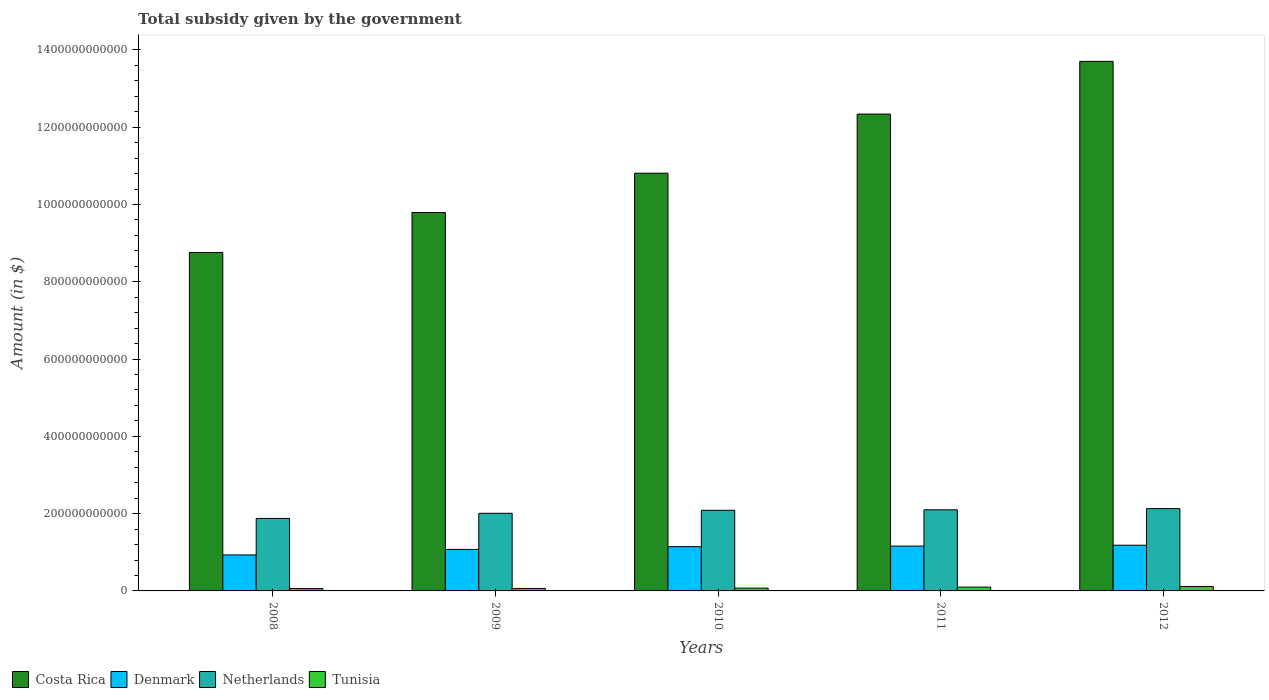How many different coloured bars are there?
Offer a very short reply. 4. Are the number of bars per tick equal to the number of legend labels?
Your answer should be very brief. Yes. How many bars are there on the 1st tick from the right?
Your answer should be compact. 4. In how many cases, is the number of bars for a given year not equal to the number of legend labels?
Offer a terse response. 0. What is the total revenue collected by the government in Tunisia in 2010?
Keep it short and to the point. 7.24e+09. Across all years, what is the maximum total revenue collected by the government in Netherlands?
Offer a very short reply. 2.13e+11. Across all years, what is the minimum total revenue collected by the government in Costa Rica?
Give a very brief answer. 8.76e+11. In which year was the total revenue collected by the government in Netherlands maximum?
Offer a terse response. 2012. What is the total total revenue collected by the government in Tunisia in the graph?
Offer a very short reply. 4.12e+1. What is the difference between the total revenue collected by the government in Denmark in 2009 and that in 2011?
Keep it short and to the point. -8.61e+09. What is the difference between the total revenue collected by the government in Tunisia in 2008 and the total revenue collected by the government in Costa Rica in 2011?
Your answer should be very brief. -1.23e+12. What is the average total revenue collected by the government in Tunisia per year?
Your answer should be very brief. 8.24e+09. In the year 2012, what is the difference between the total revenue collected by the government in Tunisia and total revenue collected by the government in Costa Rica?
Your answer should be compact. -1.36e+12. What is the ratio of the total revenue collected by the government in Costa Rica in 2008 to that in 2012?
Your answer should be very brief. 0.64. What is the difference between the highest and the second highest total revenue collected by the government in Costa Rica?
Your answer should be very brief. 1.36e+11. What is the difference between the highest and the lowest total revenue collected by the government in Costa Rica?
Provide a short and direct response. 4.95e+11. In how many years, is the total revenue collected by the government in Tunisia greater than the average total revenue collected by the government in Tunisia taken over all years?
Provide a short and direct response. 2. What does the 1st bar from the right in 2011 represents?
Ensure brevity in your answer.  Tunisia. Is it the case that in every year, the sum of the total revenue collected by the government in Denmark and total revenue collected by the government in Netherlands is greater than the total revenue collected by the government in Tunisia?
Give a very brief answer. Yes. How many bars are there?
Your response must be concise. 20. What is the difference between two consecutive major ticks on the Y-axis?
Give a very brief answer. 2.00e+11. Are the values on the major ticks of Y-axis written in scientific E-notation?
Ensure brevity in your answer.  No. Does the graph contain any zero values?
Offer a very short reply. No. Does the graph contain grids?
Your response must be concise. No. Where does the legend appear in the graph?
Keep it short and to the point. Bottom left. What is the title of the graph?
Provide a succinct answer. Total subsidy given by the government. What is the label or title of the X-axis?
Keep it short and to the point. Years. What is the label or title of the Y-axis?
Your response must be concise. Amount (in $). What is the Amount (in $) in Costa Rica in 2008?
Give a very brief answer. 8.76e+11. What is the Amount (in $) in Denmark in 2008?
Your answer should be compact. 9.31e+1. What is the Amount (in $) in Netherlands in 2008?
Your answer should be very brief. 1.88e+11. What is the Amount (in $) in Tunisia in 2008?
Keep it short and to the point. 6.13e+09. What is the Amount (in $) of Costa Rica in 2009?
Your answer should be compact. 9.79e+11. What is the Amount (in $) in Denmark in 2009?
Offer a terse response. 1.07e+11. What is the Amount (in $) of Netherlands in 2009?
Offer a terse response. 2.01e+11. What is the Amount (in $) of Tunisia in 2009?
Offer a very short reply. 6.41e+09. What is the Amount (in $) of Costa Rica in 2010?
Provide a succinct answer. 1.08e+12. What is the Amount (in $) in Denmark in 2010?
Ensure brevity in your answer.  1.15e+11. What is the Amount (in $) in Netherlands in 2010?
Keep it short and to the point. 2.09e+11. What is the Amount (in $) in Tunisia in 2010?
Your answer should be compact. 7.24e+09. What is the Amount (in $) in Costa Rica in 2011?
Offer a very short reply. 1.23e+12. What is the Amount (in $) of Denmark in 2011?
Ensure brevity in your answer.  1.16e+11. What is the Amount (in $) in Netherlands in 2011?
Keep it short and to the point. 2.10e+11. What is the Amount (in $) in Tunisia in 2011?
Offer a terse response. 9.89e+09. What is the Amount (in $) in Costa Rica in 2012?
Your answer should be compact. 1.37e+12. What is the Amount (in $) of Denmark in 2012?
Your answer should be compact. 1.18e+11. What is the Amount (in $) in Netherlands in 2012?
Offer a very short reply. 2.13e+11. What is the Amount (in $) of Tunisia in 2012?
Your answer should be compact. 1.15e+1. Across all years, what is the maximum Amount (in $) of Costa Rica?
Ensure brevity in your answer.  1.37e+12. Across all years, what is the maximum Amount (in $) in Denmark?
Keep it short and to the point. 1.18e+11. Across all years, what is the maximum Amount (in $) of Netherlands?
Your answer should be very brief. 2.13e+11. Across all years, what is the maximum Amount (in $) of Tunisia?
Offer a very short reply. 1.15e+1. Across all years, what is the minimum Amount (in $) of Costa Rica?
Offer a very short reply. 8.76e+11. Across all years, what is the minimum Amount (in $) of Denmark?
Your answer should be compact. 9.31e+1. Across all years, what is the minimum Amount (in $) in Netherlands?
Your answer should be very brief. 1.88e+11. Across all years, what is the minimum Amount (in $) of Tunisia?
Give a very brief answer. 6.13e+09. What is the total Amount (in $) of Costa Rica in the graph?
Provide a short and direct response. 5.54e+12. What is the total Amount (in $) of Denmark in the graph?
Your answer should be very brief. 5.49e+11. What is the total Amount (in $) of Netherlands in the graph?
Provide a short and direct response. 1.02e+12. What is the total Amount (in $) of Tunisia in the graph?
Offer a very short reply. 4.12e+1. What is the difference between the Amount (in $) of Costa Rica in 2008 and that in 2009?
Offer a terse response. -1.03e+11. What is the difference between the Amount (in $) of Denmark in 2008 and that in 2009?
Ensure brevity in your answer.  -1.43e+1. What is the difference between the Amount (in $) in Netherlands in 2008 and that in 2009?
Your answer should be compact. -1.33e+1. What is the difference between the Amount (in $) of Tunisia in 2008 and that in 2009?
Provide a short and direct response. -2.86e+08. What is the difference between the Amount (in $) in Costa Rica in 2008 and that in 2010?
Offer a very short reply. -2.05e+11. What is the difference between the Amount (in $) of Denmark in 2008 and that in 2010?
Provide a succinct answer. -2.14e+1. What is the difference between the Amount (in $) of Netherlands in 2008 and that in 2010?
Give a very brief answer. -2.10e+1. What is the difference between the Amount (in $) in Tunisia in 2008 and that in 2010?
Keep it short and to the point. -1.11e+09. What is the difference between the Amount (in $) of Costa Rica in 2008 and that in 2011?
Provide a short and direct response. -3.58e+11. What is the difference between the Amount (in $) in Denmark in 2008 and that in 2011?
Keep it short and to the point. -2.29e+1. What is the difference between the Amount (in $) in Netherlands in 2008 and that in 2011?
Give a very brief answer. -2.23e+1. What is the difference between the Amount (in $) in Tunisia in 2008 and that in 2011?
Offer a terse response. -3.76e+09. What is the difference between the Amount (in $) in Costa Rica in 2008 and that in 2012?
Offer a terse response. -4.95e+11. What is the difference between the Amount (in $) of Denmark in 2008 and that in 2012?
Your response must be concise. -2.52e+1. What is the difference between the Amount (in $) in Netherlands in 2008 and that in 2012?
Offer a very short reply. -2.55e+1. What is the difference between the Amount (in $) in Tunisia in 2008 and that in 2012?
Make the answer very short. -5.40e+09. What is the difference between the Amount (in $) of Costa Rica in 2009 and that in 2010?
Provide a short and direct response. -1.02e+11. What is the difference between the Amount (in $) of Denmark in 2009 and that in 2010?
Your answer should be compact. -7.08e+09. What is the difference between the Amount (in $) in Netherlands in 2009 and that in 2010?
Give a very brief answer. -7.71e+09. What is the difference between the Amount (in $) in Tunisia in 2009 and that in 2010?
Your response must be concise. -8.23e+08. What is the difference between the Amount (in $) in Costa Rica in 2009 and that in 2011?
Provide a short and direct response. -2.55e+11. What is the difference between the Amount (in $) of Denmark in 2009 and that in 2011?
Make the answer very short. -8.61e+09. What is the difference between the Amount (in $) in Netherlands in 2009 and that in 2011?
Ensure brevity in your answer.  -8.99e+09. What is the difference between the Amount (in $) in Tunisia in 2009 and that in 2011?
Provide a short and direct response. -3.48e+09. What is the difference between the Amount (in $) in Costa Rica in 2009 and that in 2012?
Give a very brief answer. -3.91e+11. What is the difference between the Amount (in $) of Denmark in 2009 and that in 2012?
Keep it short and to the point. -1.09e+1. What is the difference between the Amount (in $) in Netherlands in 2009 and that in 2012?
Your answer should be very brief. -1.22e+1. What is the difference between the Amount (in $) of Tunisia in 2009 and that in 2012?
Your answer should be very brief. -5.11e+09. What is the difference between the Amount (in $) of Costa Rica in 2010 and that in 2011?
Offer a very short reply. -1.53e+11. What is the difference between the Amount (in $) in Denmark in 2010 and that in 2011?
Provide a succinct answer. -1.53e+09. What is the difference between the Amount (in $) in Netherlands in 2010 and that in 2011?
Offer a very short reply. -1.28e+09. What is the difference between the Amount (in $) of Tunisia in 2010 and that in 2011?
Provide a succinct answer. -2.66e+09. What is the difference between the Amount (in $) in Costa Rica in 2010 and that in 2012?
Provide a succinct answer. -2.89e+11. What is the difference between the Amount (in $) in Denmark in 2010 and that in 2012?
Provide a short and direct response. -3.80e+09. What is the difference between the Amount (in $) in Netherlands in 2010 and that in 2012?
Make the answer very short. -4.46e+09. What is the difference between the Amount (in $) in Tunisia in 2010 and that in 2012?
Give a very brief answer. -4.29e+09. What is the difference between the Amount (in $) of Costa Rica in 2011 and that in 2012?
Offer a terse response. -1.36e+11. What is the difference between the Amount (in $) in Denmark in 2011 and that in 2012?
Give a very brief answer. -2.27e+09. What is the difference between the Amount (in $) of Netherlands in 2011 and that in 2012?
Make the answer very short. -3.18e+09. What is the difference between the Amount (in $) of Tunisia in 2011 and that in 2012?
Your response must be concise. -1.64e+09. What is the difference between the Amount (in $) in Costa Rica in 2008 and the Amount (in $) in Denmark in 2009?
Give a very brief answer. 7.68e+11. What is the difference between the Amount (in $) in Costa Rica in 2008 and the Amount (in $) in Netherlands in 2009?
Ensure brevity in your answer.  6.75e+11. What is the difference between the Amount (in $) in Costa Rica in 2008 and the Amount (in $) in Tunisia in 2009?
Your answer should be very brief. 8.69e+11. What is the difference between the Amount (in $) in Denmark in 2008 and the Amount (in $) in Netherlands in 2009?
Your response must be concise. -1.08e+11. What is the difference between the Amount (in $) in Denmark in 2008 and the Amount (in $) in Tunisia in 2009?
Offer a very short reply. 8.67e+1. What is the difference between the Amount (in $) in Netherlands in 2008 and the Amount (in $) in Tunisia in 2009?
Your answer should be compact. 1.81e+11. What is the difference between the Amount (in $) of Costa Rica in 2008 and the Amount (in $) of Denmark in 2010?
Your response must be concise. 7.61e+11. What is the difference between the Amount (in $) of Costa Rica in 2008 and the Amount (in $) of Netherlands in 2010?
Your answer should be very brief. 6.67e+11. What is the difference between the Amount (in $) in Costa Rica in 2008 and the Amount (in $) in Tunisia in 2010?
Give a very brief answer. 8.69e+11. What is the difference between the Amount (in $) of Denmark in 2008 and the Amount (in $) of Netherlands in 2010?
Provide a short and direct response. -1.15e+11. What is the difference between the Amount (in $) of Denmark in 2008 and the Amount (in $) of Tunisia in 2010?
Offer a very short reply. 8.59e+1. What is the difference between the Amount (in $) of Netherlands in 2008 and the Amount (in $) of Tunisia in 2010?
Ensure brevity in your answer.  1.80e+11. What is the difference between the Amount (in $) of Costa Rica in 2008 and the Amount (in $) of Denmark in 2011?
Your answer should be compact. 7.60e+11. What is the difference between the Amount (in $) in Costa Rica in 2008 and the Amount (in $) in Netherlands in 2011?
Provide a succinct answer. 6.66e+11. What is the difference between the Amount (in $) of Costa Rica in 2008 and the Amount (in $) of Tunisia in 2011?
Offer a terse response. 8.66e+11. What is the difference between the Amount (in $) of Denmark in 2008 and the Amount (in $) of Netherlands in 2011?
Your answer should be very brief. -1.17e+11. What is the difference between the Amount (in $) in Denmark in 2008 and the Amount (in $) in Tunisia in 2011?
Make the answer very short. 8.32e+1. What is the difference between the Amount (in $) in Netherlands in 2008 and the Amount (in $) in Tunisia in 2011?
Your answer should be compact. 1.78e+11. What is the difference between the Amount (in $) of Costa Rica in 2008 and the Amount (in $) of Denmark in 2012?
Make the answer very short. 7.58e+11. What is the difference between the Amount (in $) of Costa Rica in 2008 and the Amount (in $) of Netherlands in 2012?
Provide a succinct answer. 6.63e+11. What is the difference between the Amount (in $) of Costa Rica in 2008 and the Amount (in $) of Tunisia in 2012?
Your answer should be compact. 8.64e+11. What is the difference between the Amount (in $) in Denmark in 2008 and the Amount (in $) in Netherlands in 2012?
Your answer should be very brief. -1.20e+11. What is the difference between the Amount (in $) of Denmark in 2008 and the Amount (in $) of Tunisia in 2012?
Make the answer very short. 8.16e+1. What is the difference between the Amount (in $) in Netherlands in 2008 and the Amount (in $) in Tunisia in 2012?
Your response must be concise. 1.76e+11. What is the difference between the Amount (in $) of Costa Rica in 2009 and the Amount (in $) of Denmark in 2010?
Offer a terse response. 8.65e+11. What is the difference between the Amount (in $) in Costa Rica in 2009 and the Amount (in $) in Netherlands in 2010?
Offer a terse response. 7.71e+11. What is the difference between the Amount (in $) in Costa Rica in 2009 and the Amount (in $) in Tunisia in 2010?
Offer a terse response. 9.72e+11. What is the difference between the Amount (in $) of Denmark in 2009 and the Amount (in $) of Netherlands in 2010?
Offer a terse response. -1.01e+11. What is the difference between the Amount (in $) in Denmark in 2009 and the Amount (in $) in Tunisia in 2010?
Ensure brevity in your answer.  1.00e+11. What is the difference between the Amount (in $) in Netherlands in 2009 and the Amount (in $) in Tunisia in 2010?
Your answer should be compact. 1.94e+11. What is the difference between the Amount (in $) in Costa Rica in 2009 and the Amount (in $) in Denmark in 2011?
Your answer should be compact. 8.63e+11. What is the difference between the Amount (in $) in Costa Rica in 2009 and the Amount (in $) in Netherlands in 2011?
Offer a terse response. 7.69e+11. What is the difference between the Amount (in $) in Costa Rica in 2009 and the Amount (in $) in Tunisia in 2011?
Make the answer very short. 9.69e+11. What is the difference between the Amount (in $) of Denmark in 2009 and the Amount (in $) of Netherlands in 2011?
Give a very brief answer. -1.02e+11. What is the difference between the Amount (in $) of Denmark in 2009 and the Amount (in $) of Tunisia in 2011?
Offer a very short reply. 9.75e+1. What is the difference between the Amount (in $) of Netherlands in 2009 and the Amount (in $) of Tunisia in 2011?
Offer a terse response. 1.91e+11. What is the difference between the Amount (in $) in Costa Rica in 2009 and the Amount (in $) in Denmark in 2012?
Your answer should be compact. 8.61e+11. What is the difference between the Amount (in $) of Costa Rica in 2009 and the Amount (in $) of Netherlands in 2012?
Offer a terse response. 7.66e+11. What is the difference between the Amount (in $) in Costa Rica in 2009 and the Amount (in $) in Tunisia in 2012?
Make the answer very short. 9.68e+11. What is the difference between the Amount (in $) in Denmark in 2009 and the Amount (in $) in Netherlands in 2012?
Provide a short and direct response. -1.06e+11. What is the difference between the Amount (in $) in Denmark in 2009 and the Amount (in $) in Tunisia in 2012?
Provide a succinct answer. 9.59e+1. What is the difference between the Amount (in $) in Netherlands in 2009 and the Amount (in $) in Tunisia in 2012?
Offer a terse response. 1.89e+11. What is the difference between the Amount (in $) in Costa Rica in 2010 and the Amount (in $) in Denmark in 2011?
Your answer should be compact. 9.65e+11. What is the difference between the Amount (in $) of Costa Rica in 2010 and the Amount (in $) of Netherlands in 2011?
Your response must be concise. 8.71e+11. What is the difference between the Amount (in $) in Costa Rica in 2010 and the Amount (in $) in Tunisia in 2011?
Ensure brevity in your answer.  1.07e+12. What is the difference between the Amount (in $) of Denmark in 2010 and the Amount (in $) of Netherlands in 2011?
Make the answer very short. -9.54e+1. What is the difference between the Amount (in $) in Denmark in 2010 and the Amount (in $) in Tunisia in 2011?
Provide a short and direct response. 1.05e+11. What is the difference between the Amount (in $) of Netherlands in 2010 and the Amount (in $) of Tunisia in 2011?
Provide a short and direct response. 1.99e+11. What is the difference between the Amount (in $) of Costa Rica in 2010 and the Amount (in $) of Denmark in 2012?
Your response must be concise. 9.63e+11. What is the difference between the Amount (in $) in Costa Rica in 2010 and the Amount (in $) in Netherlands in 2012?
Your answer should be compact. 8.68e+11. What is the difference between the Amount (in $) in Costa Rica in 2010 and the Amount (in $) in Tunisia in 2012?
Your answer should be compact. 1.07e+12. What is the difference between the Amount (in $) in Denmark in 2010 and the Amount (in $) in Netherlands in 2012?
Offer a terse response. -9.86e+1. What is the difference between the Amount (in $) in Denmark in 2010 and the Amount (in $) in Tunisia in 2012?
Your answer should be very brief. 1.03e+11. What is the difference between the Amount (in $) in Netherlands in 2010 and the Amount (in $) in Tunisia in 2012?
Provide a short and direct response. 1.97e+11. What is the difference between the Amount (in $) of Costa Rica in 2011 and the Amount (in $) of Denmark in 2012?
Make the answer very short. 1.12e+12. What is the difference between the Amount (in $) in Costa Rica in 2011 and the Amount (in $) in Netherlands in 2012?
Your response must be concise. 1.02e+12. What is the difference between the Amount (in $) in Costa Rica in 2011 and the Amount (in $) in Tunisia in 2012?
Offer a very short reply. 1.22e+12. What is the difference between the Amount (in $) of Denmark in 2011 and the Amount (in $) of Netherlands in 2012?
Make the answer very short. -9.70e+1. What is the difference between the Amount (in $) of Denmark in 2011 and the Amount (in $) of Tunisia in 2012?
Ensure brevity in your answer.  1.05e+11. What is the difference between the Amount (in $) of Netherlands in 2011 and the Amount (in $) of Tunisia in 2012?
Make the answer very short. 1.98e+11. What is the average Amount (in $) in Costa Rica per year?
Your response must be concise. 1.11e+12. What is the average Amount (in $) in Denmark per year?
Your response must be concise. 1.10e+11. What is the average Amount (in $) in Netherlands per year?
Offer a terse response. 2.04e+11. What is the average Amount (in $) in Tunisia per year?
Provide a succinct answer. 8.24e+09. In the year 2008, what is the difference between the Amount (in $) in Costa Rica and Amount (in $) in Denmark?
Give a very brief answer. 7.83e+11. In the year 2008, what is the difference between the Amount (in $) in Costa Rica and Amount (in $) in Netherlands?
Provide a short and direct response. 6.88e+11. In the year 2008, what is the difference between the Amount (in $) of Costa Rica and Amount (in $) of Tunisia?
Ensure brevity in your answer.  8.70e+11. In the year 2008, what is the difference between the Amount (in $) of Denmark and Amount (in $) of Netherlands?
Your response must be concise. -9.45e+1. In the year 2008, what is the difference between the Amount (in $) in Denmark and Amount (in $) in Tunisia?
Give a very brief answer. 8.70e+1. In the year 2008, what is the difference between the Amount (in $) in Netherlands and Amount (in $) in Tunisia?
Give a very brief answer. 1.81e+11. In the year 2009, what is the difference between the Amount (in $) of Costa Rica and Amount (in $) of Denmark?
Give a very brief answer. 8.72e+11. In the year 2009, what is the difference between the Amount (in $) of Costa Rica and Amount (in $) of Netherlands?
Make the answer very short. 7.78e+11. In the year 2009, what is the difference between the Amount (in $) in Costa Rica and Amount (in $) in Tunisia?
Give a very brief answer. 9.73e+11. In the year 2009, what is the difference between the Amount (in $) in Denmark and Amount (in $) in Netherlands?
Offer a very short reply. -9.35e+1. In the year 2009, what is the difference between the Amount (in $) in Denmark and Amount (in $) in Tunisia?
Provide a short and direct response. 1.01e+11. In the year 2009, what is the difference between the Amount (in $) in Netherlands and Amount (in $) in Tunisia?
Provide a succinct answer. 1.94e+11. In the year 2010, what is the difference between the Amount (in $) of Costa Rica and Amount (in $) of Denmark?
Ensure brevity in your answer.  9.67e+11. In the year 2010, what is the difference between the Amount (in $) of Costa Rica and Amount (in $) of Netherlands?
Your answer should be compact. 8.72e+11. In the year 2010, what is the difference between the Amount (in $) in Costa Rica and Amount (in $) in Tunisia?
Your answer should be compact. 1.07e+12. In the year 2010, what is the difference between the Amount (in $) of Denmark and Amount (in $) of Netherlands?
Offer a very short reply. -9.41e+1. In the year 2010, what is the difference between the Amount (in $) of Denmark and Amount (in $) of Tunisia?
Offer a very short reply. 1.07e+11. In the year 2010, what is the difference between the Amount (in $) in Netherlands and Amount (in $) in Tunisia?
Your answer should be compact. 2.01e+11. In the year 2011, what is the difference between the Amount (in $) in Costa Rica and Amount (in $) in Denmark?
Offer a very short reply. 1.12e+12. In the year 2011, what is the difference between the Amount (in $) of Costa Rica and Amount (in $) of Netherlands?
Your answer should be compact. 1.02e+12. In the year 2011, what is the difference between the Amount (in $) of Costa Rica and Amount (in $) of Tunisia?
Offer a very short reply. 1.22e+12. In the year 2011, what is the difference between the Amount (in $) of Denmark and Amount (in $) of Netherlands?
Provide a succinct answer. -9.39e+1. In the year 2011, what is the difference between the Amount (in $) of Denmark and Amount (in $) of Tunisia?
Provide a succinct answer. 1.06e+11. In the year 2011, what is the difference between the Amount (in $) of Netherlands and Amount (in $) of Tunisia?
Give a very brief answer. 2.00e+11. In the year 2012, what is the difference between the Amount (in $) of Costa Rica and Amount (in $) of Denmark?
Offer a terse response. 1.25e+12. In the year 2012, what is the difference between the Amount (in $) in Costa Rica and Amount (in $) in Netherlands?
Your answer should be compact. 1.16e+12. In the year 2012, what is the difference between the Amount (in $) in Costa Rica and Amount (in $) in Tunisia?
Ensure brevity in your answer.  1.36e+12. In the year 2012, what is the difference between the Amount (in $) of Denmark and Amount (in $) of Netherlands?
Offer a very short reply. -9.48e+1. In the year 2012, what is the difference between the Amount (in $) of Denmark and Amount (in $) of Tunisia?
Offer a terse response. 1.07e+11. In the year 2012, what is the difference between the Amount (in $) of Netherlands and Amount (in $) of Tunisia?
Keep it short and to the point. 2.02e+11. What is the ratio of the Amount (in $) in Costa Rica in 2008 to that in 2009?
Ensure brevity in your answer.  0.89. What is the ratio of the Amount (in $) of Denmark in 2008 to that in 2009?
Offer a terse response. 0.87. What is the ratio of the Amount (in $) in Netherlands in 2008 to that in 2009?
Your answer should be compact. 0.93. What is the ratio of the Amount (in $) in Tunisia in 2008 to that in 2009?
Give a very brief answer. 0.96. What is the ratio of the Amount (in $) of Costa Rica in 2008 to that in 2010?
Provide a short and direct response. 0.81. What is the ratio of the Amount (in $) in Denmark in 2008 to that in 2010?
Provide a succinct answer. 0.81. What is the ratio of the Amount (in $) in Netherlands in 2008 to that in 2010?
Provide a succinct answer. 0.9. What is the ratio of the Amount (in $) of Tunisia in 2008 to that in 2010?
Your answer should be very brief. 0.85. What is the ratio of the Amount (in $) in Costa Rica in 2008 to that in 2011?
Make the answer very short. 0.71. What is the ratio of the Amount (in $) in Denmark in 2008 to that in 2011?
Provide a succinct answer. 0.8. What is the ratio of the Amount (in $) in Netherlands in 2008 to that in 2011?
Offer a very short reply. 0.89. What is the ratio of the Amount (in $) of Tunisia in 2008 to that in 2011?
Provide a succinct answer. 0.62. What is the ratio of the Amount (in $) in Costa Rica in 2008 to that in 2012?
Provide a short and direct response. 0.64. What is the ratio of the Amount (in $) of Denmark in 2008 to that in 2012?
Provide a succinct answer. 0.79. What is the ratio of the Amount (in $) in Netherlands in 2008 to that in 2012?
Your answer should be very brief. 0.88. What is the ratio of the Amount (in $) in Tunisia in 2008 to that in 2012?
Offer a terse response. 0.53. What is the ratio of the Amount (in $) of Costa Rica in 2009 to that in 2010?
Give a very brief answer. 0.91. What is the ratio of the Amount (in $) of Denmark in 2009 to that in 2010?
Keep it short and to the point. 0.94. What is the ratio of the Amount (in $) of Netherlands in 2009 to that in 2010?
Offer a terse response. 0.96. What is the ratio of the Amount (in $) of Tunisia in 2009 to that in 2010?
Offer a terse response. 0.89. What is the ratio of the Amount (in $) of Costa Rica in 2009 to that in 2011?
Provide a succinct answer. 0.79. What is the ratio of the Amount (in $) in Denmark in 2009 to that in 2011?
Ensure brevity in your answer.  0.93. What is the ratio of the Amount (in $) in Netherlands in 2009 to that in 2011?
Keep it short and to the point. 0.96. What is the ratio of the Amount (in $) of Tunisia in 2009 to that in 2011?
Your answer should be very brief. 0.65. What is the ratio of the Amount (in $) in Costa Rica in 2009 to that in 2012?
Your answer should be very brief. 0.71. What is the ratio of the Amount (in $) in Denmark in 2009 to that in 2012?
Provide a short and direct response. 0.91. What is the ratio of the Amount (in $) in Netherlands in 2009 to that in 2012?
Provide a short and direct response. 0.94. What is the ratio of the Amount (in $) of Tunisia in 2009 to that in 2012?
Your response must be concise. 0.56. What is the ratio of the Amount (in $) in Costa Rica in 2010 to that in 2011?
Offer a very short reply. 0.88. What is the ratio of the Amount (in $) of Denmark in 2010 to that in 2011?
Keep it short and to the point. 0.99. What is the ratio of the Amount (in $) in Tunisia in 2010 to that in 2011?
Offer a very short reply. 0.73. What is the ratio of the Amount (in $) of Costa Rica in 2010 to that in 2012?
Your answer should be compact. 0.79. What is the ratio of the Amount (in $) in Denmark in 2010 to that in 2012?
Offer a very short reply. 0.97. What is the ratio of the Amount (in $) of Netherlands in 2010 to that in 2012?
Your response must be concise. 0.98. What is the ratio of the Amount (in $) of Tunisia in 2010 to that in 2012?
Your response must be concise. 0.63. What is the ratio of the Amount (in $) of Costa Rica in 2011 to that in 2012?
Your response must be concise. 0.9. What is the ratio of the Amount (in $) of Denmark in 2011 to that in 2012?
Keep it short and to the point. 0.98. What is the ratio of the Amount (in $) in Netherlands in 2011 to that in 2012?
Offer a terse response. 0.99. What is the ratio of the Amount (in $) of Tunisia in 2011 to that in 2012?
Ensure brevity in your answer.  0.86. What is the difference between the highest and the second highest Amount (in $) in Costa Rica?
Provide a succinct answer. 1.36e+11. What is the difference between the highest and the second highest Amount (in $) of Denmark?
Provide a succinct answer. 2.27e+09. What is the difference between the highest and the second highest Amount (in $) in Netherlands?
Give a very brief answer. 3.18e+09. What is the difference between the highest and the second highest Amount (in $) of Tunisia?
Provide a succinct answer. 1.64e+09. What is the difference between the highest and the lowest Amount (in $) in Costa Rica?
Offer a very short reply. 4.95e+11. What is the difference between the highest and the lowest Amount (in $) of Denmark?
Provide a succinct answer. 2.52e+1. What is the difference between the highest and the lowest Amount (in $) in Netherlands?
Your response must be concise. 2.55e+1. What is the difference between the highest and the lowest Amount (in $) of Tunisia?
Offer a very short reply. 5.40e+09. 